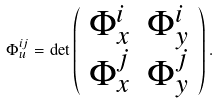Convert formula to latex. <formula><loc_0><loc_0><loc_500><loc_500>\Phi _ { u } ^ { i j } = \det \left ( \begin{array} { c c } \Phi _ { x } ^ { i } & \Phi _ { y } ^ { i } \\ \Phi _ { x } ^ { j } & \Phi _ { y } ^ { j } \end{array} \right ) .</formula> 